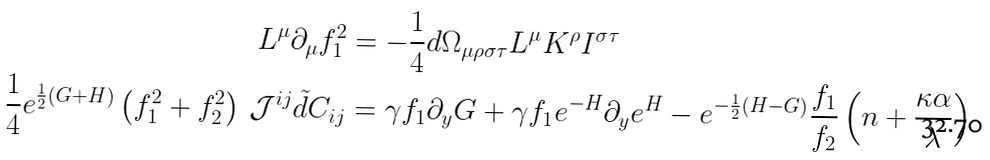<formula> <loc_0><loc_0><loc_500><loc_500>L ^ { \mu } \partial _ { \mu } f _ { 1 } ^ { 2 } & = - \frac { 1 } { 4 } d \Omega _ { \mu \rho \sigma \tau } L ^ { \mu } K ^ { \rho } I ^ { \sigma \tau } \\ \frac { 1 } { 4 } e ^ { \frac { 1 } { 2 } \left ( G + H \right ) } \left ( f _ { 1 } ^ { 2 } + f _ { 2 } ^ { 2 } \right ) \, \mathcal { J } ^ { i j } \tilde { d } C _ { i j } & = \gamma f _ { 1 } \partial _ { y } G + \gamma f _ { 1 } e ^ { - H } \partial _ { y } e ^ { H } - e ^ { - \frac { 1 } { 2 } \left ( H - G \right ) } \frac { f _ { 1 } } { f _ { 2 } } \left ( n + \frac { \kappa \alpha } { \lambda } \right )</formula> 